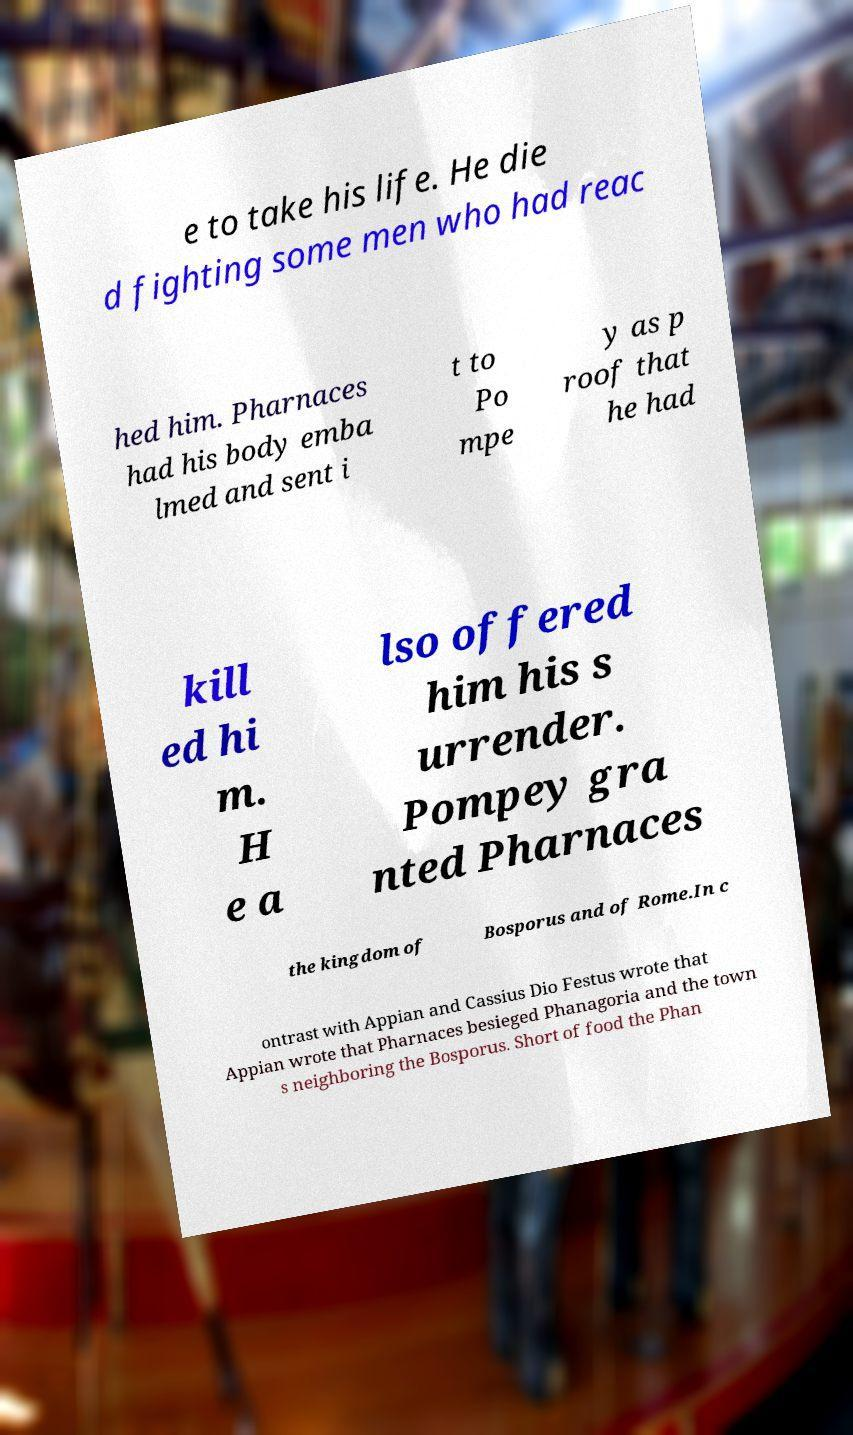Please read and relay the text visible in this image. What does it say? e to take his life. He die d fighting some men who had reac hed him. Pharnaces had his body emba lmed and sent i t to Po mpe y as p roof that he had kill ed hi m. H e a lso offered him his s urrender. Pompey gra nted Pharnaces the kingdom of Bosporus and of Rome.In c ontrast with Appian and Cassius Dio Festus wrote that Appian wrote that Pharnaces besieged Phanagoria and the town s neighboring the Bosporus. Short of food the Phan 